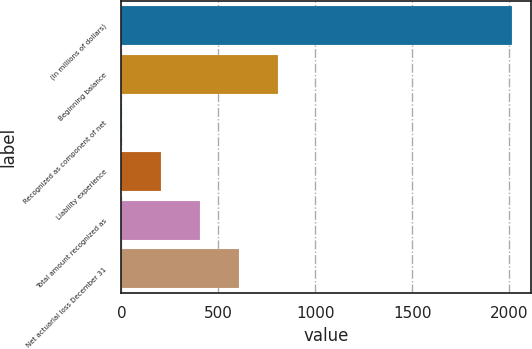<chart> <loc_0><loc_0><loc_500><loc_500><bar_chart><fcel>(In millions of dollars)<fcel>Beginning balance<fcel>Recognized as component of net<fcel>Liability experience<fcel>Total amount recognized as<fcel>Net actuarial loss December 31<nl><fcel>2014<fcel>806.2<fcel>1<fcel>202.3<fcel>403.6<fcel>604.9<nl></chart> 